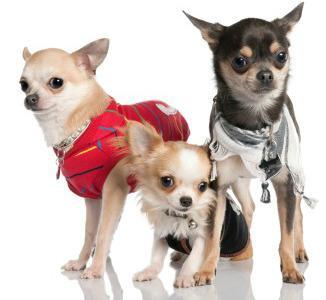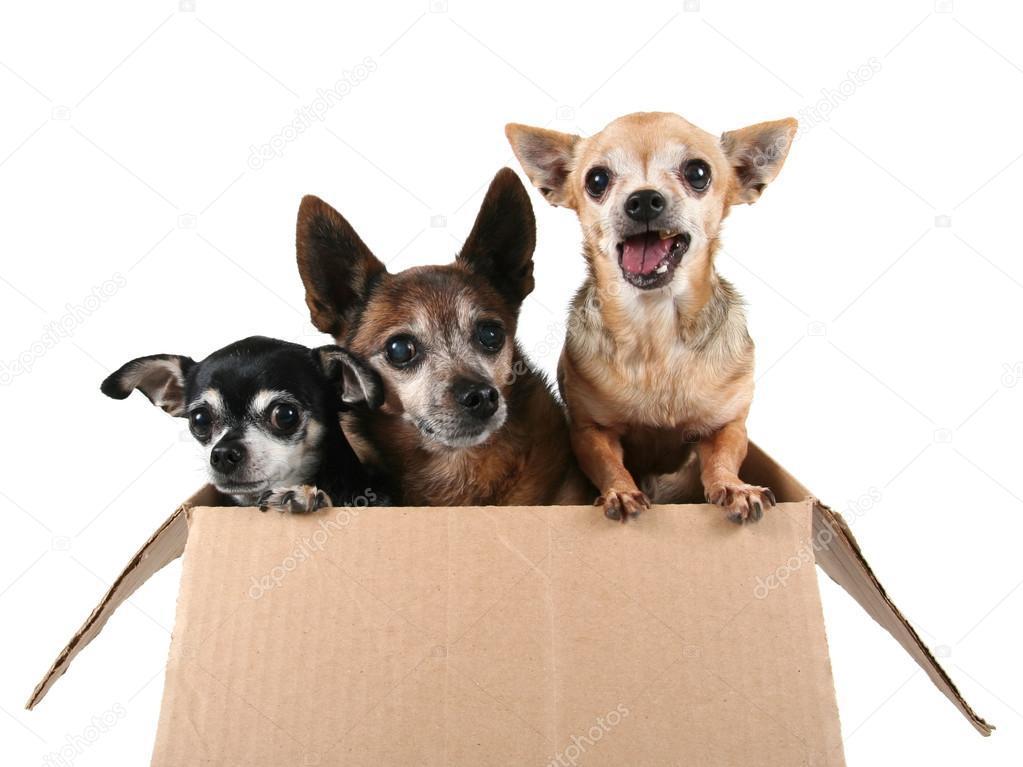The first image is the image on the left, the second image is the image on the right. For the images displayed, is the sentence "The right image contains three chihuahua's." factually correct? Answer yes or no. Yes. The first image is the image on the left, the second image is the image on the right. Considering the images on both sides, is "There is a single dog in the image on the right." valid? Answer yes or no. No. 